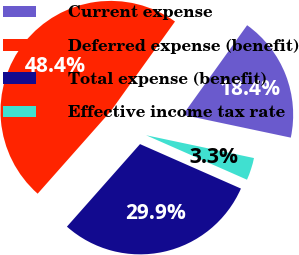Convert chart. <chart><loc_0><loc_0><loc_500><loc_500><pie_chart><fcel>Current expense<fcel>Deferred expense (benefit)<fcel>Total expense (benefit)<fcel>Effective income tax rate<nl><fcel>18.42%<fcel>48.36%<fcel>29.93%<fcel>3.29%<nl></chart> 